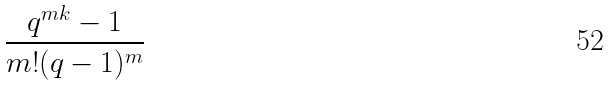<formula> <loc_0><loc_0><loc_500><loc_500>\frac { q ^ { m k } - 1 } { m ! ( q - 1 ) ^ { m } }</formula> 